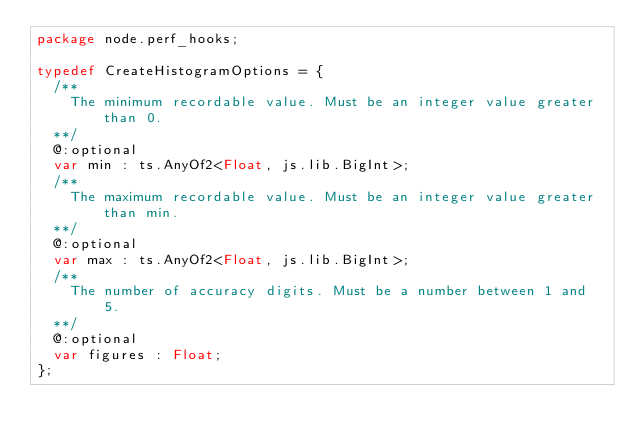Convert code to text. <code><loc_0><loc_0><loc_500><loc_500><_Haxe_>package node.perf_hooks;

typedef CreateHistogramOptions = {
	/**
		The minimum recordable value. Must be an integer value greater than 0.
	**/
	@:optional
	var min : ts.AnyOf2<Float, js.lib.BigInt>;
	/**
		The maximum recordable value. Must be an integer value greater than min.
	**/
	@:optional
	var max : ts.AnyOf2<Float, js.lib.BigInt>;
	/**
		The number of accuracy digits. Must be a number between 1 and 5.
	**/
	@:optional
	var figures : Float;
};</code> 